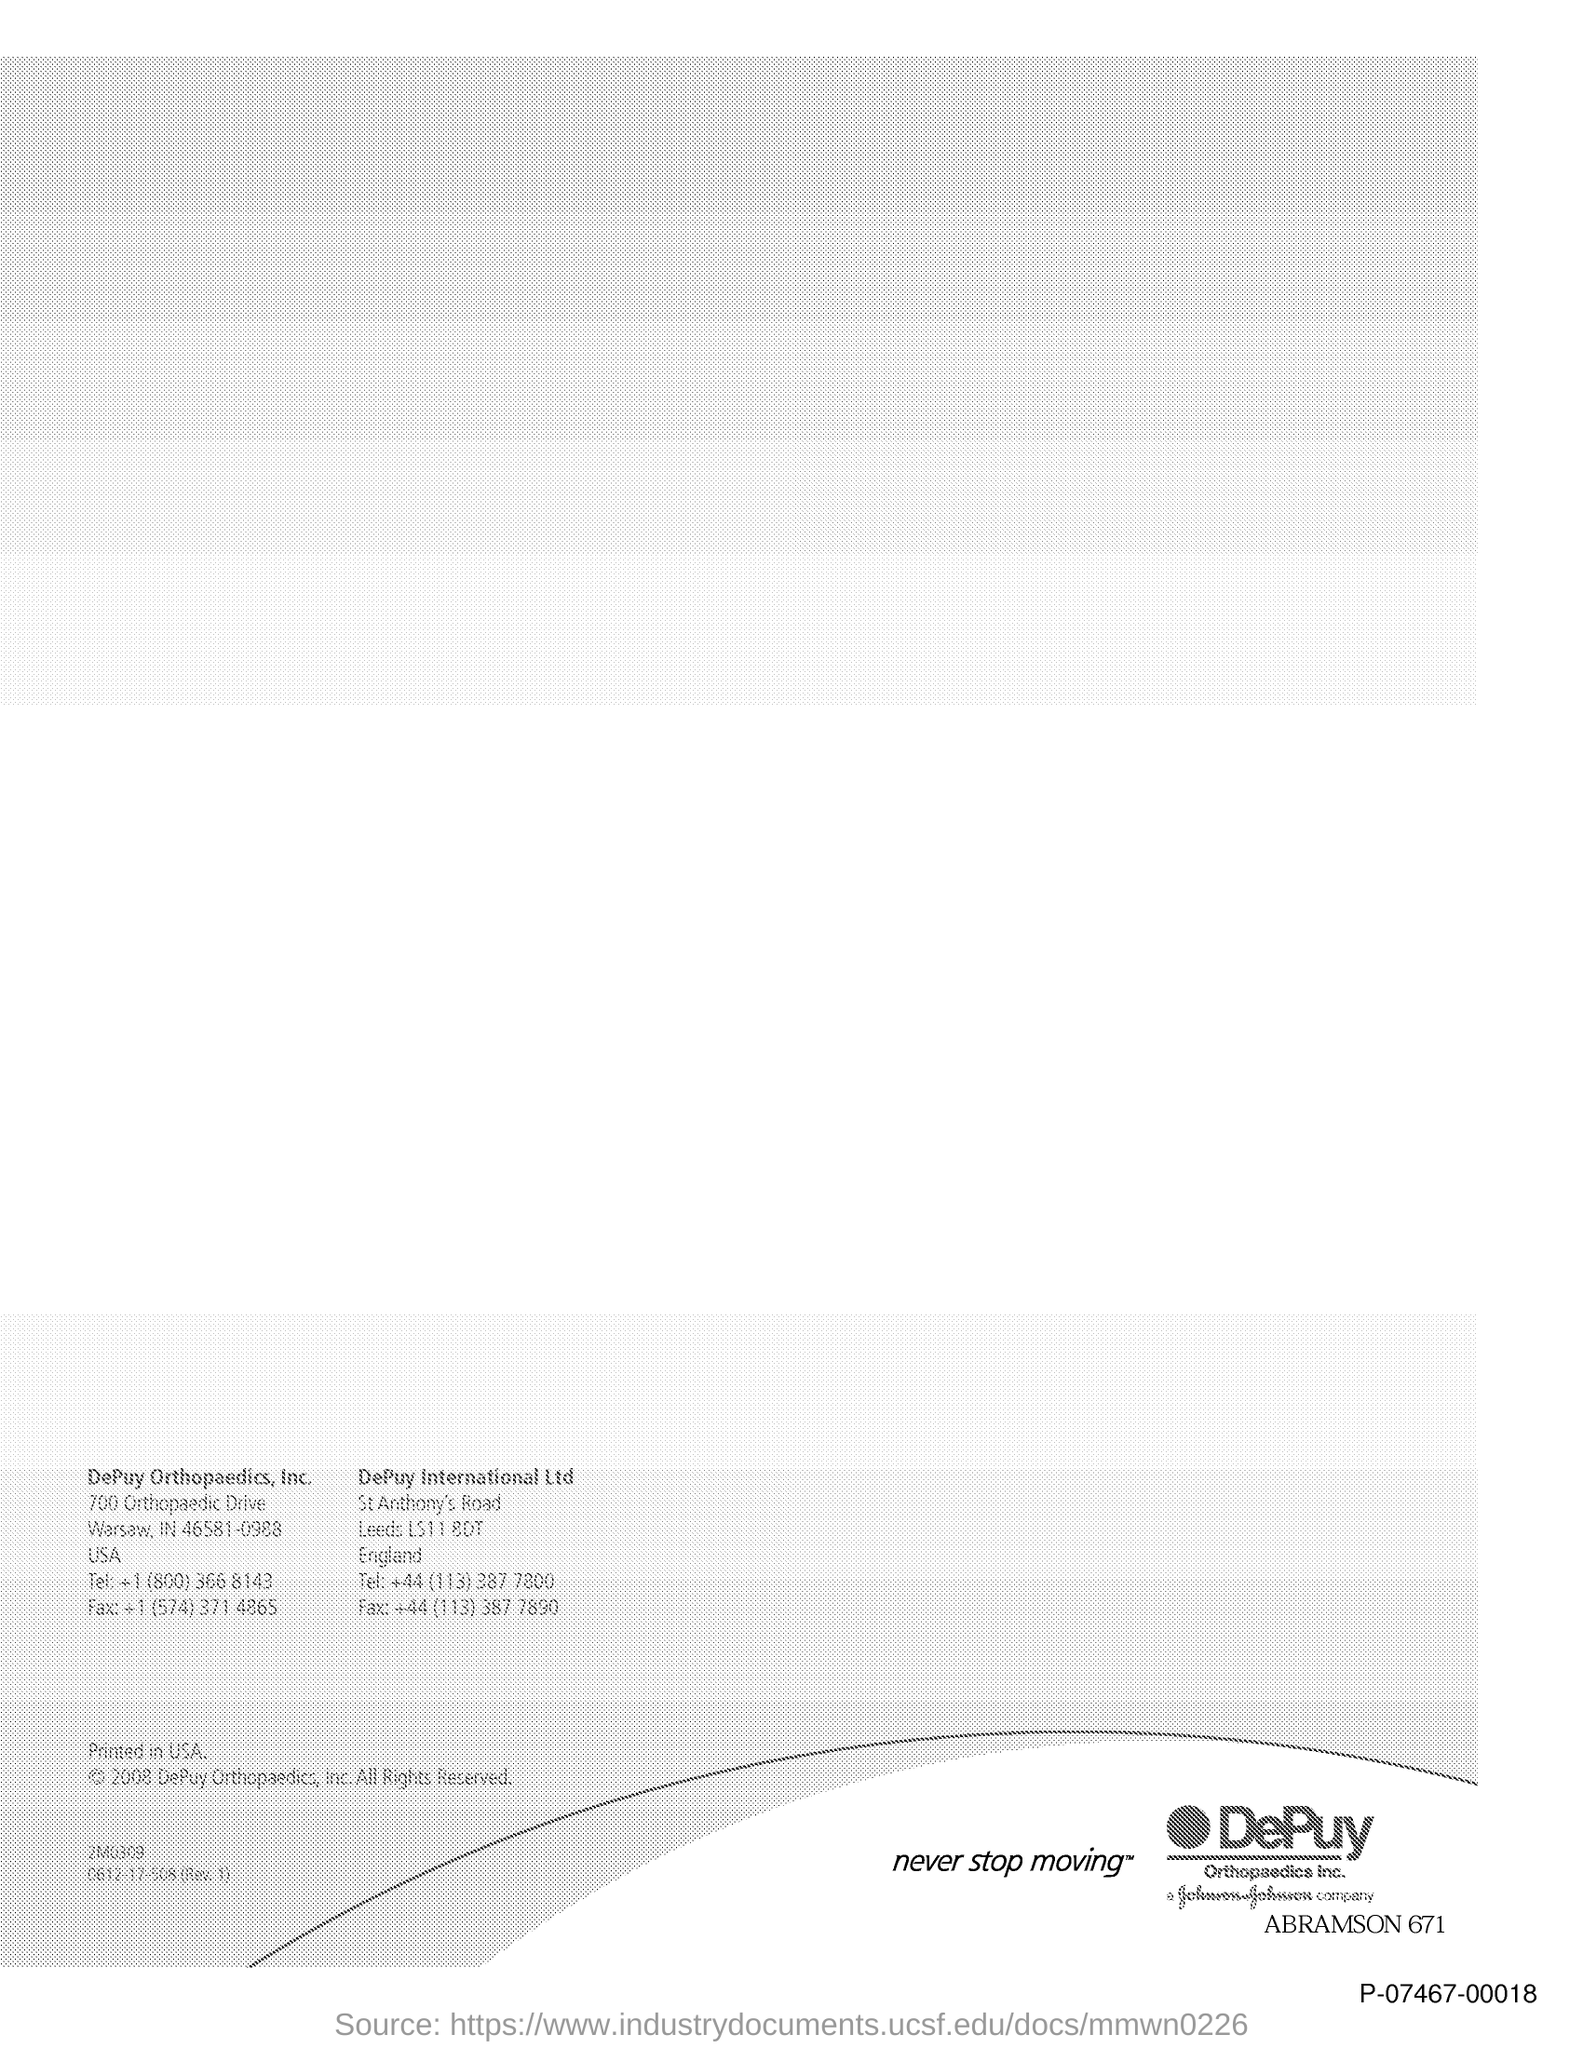What is the Tel: for DePuy International Ltd?
Your answer should be very brief. +44 (113) 387 7800. What is the Fax for DePuy International Ltd?
Offer a terse response. +44 (113) 387 7890. 